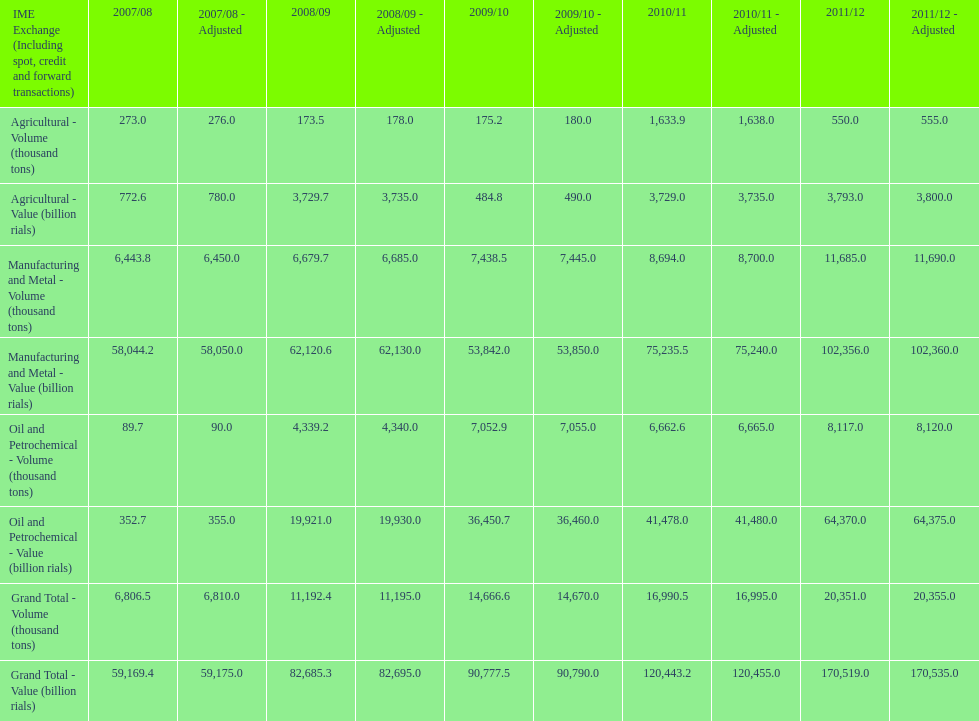I'm looking to parse the entire table for insights. Could you assist me with that? {'header': ['IME Exchange (Including spot, credit and forward transactions)', '2007/08', '2007/08 - Adjusted', '2008/09', '2008/09 - Adjusted', '2009/10', '2009/10 - Adjusted', '2010/11', '2010/11 - Adjusted', '2011/12', '2011/12 - Adjusted'], 'rows': [['Agricultural - Volume (thousand tons)', '273.0', '276.0', '173.5', '178.0', '175.2', '180.0', '1,633.9', '1,638.0', '550.0', '555.0'], ['Agricultural - Value (billion rials)', '772.6', '780.0', '3,729.7', '3,735.0', '484.8', '490.0', '3,729.0', '3,735.0', '3,793.0', '3,800.0'], ['Manufacturing and Metal - Volume (thousand tons)', '6,443.8', '6,450.0', '6,679.7', '6,685.0', '7,438.5', '7,445.0', '8,694.0', '8,700.0', '11,685.0', '11,690.0'], ['Manufacturing and Metal - Value (billion rials)', '58,044.2', '58,050.0', '62,120.6', '62,130.0', '53,842.0', '53,850.0', '75,235.5', '75,240.0', '102,356.0', '102,360.0'], ['Oil and Petrochemical - Volume (thousand tons)', '89.7', '90.0', '4,339.2', '4,340.0', '7,052.9', '7,055.0', '6,662.6', '6,665.0', '8,117.0', '8,120.0'], ['Oil and Petrochemical - Value (billion rials)', '352.7', '355.0', '19,921.0', '19,930.0', '36,450.7', '36,460.0', '41,478.0', '41,480.0', '64,370.0', '64,375.0'], ['Grand Total - Volume (thousand tons)', '6,806.5', '6,810.0', '11,192.4', '11,195.0', '14,666.6', '14,670.0', '16,990.5', '16,995.0', '20,351.0', '20,355.0'], ['Grand Total - Value (billion rials)', '59,169.4', '59,175.0', '82,685.3', '82,695.0', '90,777.5', '90,790.0', '120,443.2', '120,455.0', '170,519.0', '170,535.0']]} What year saw the greatest value for manufacturing and metal in iran? 2011/12. 